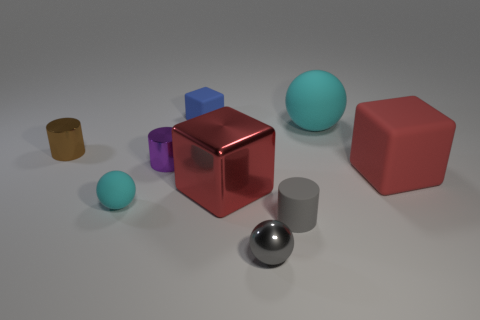How many cyan spheres must be subtracted to get 1 cyan spheres? 1 Subtract all cyan balls. How many balls are left? 1 Subtract 0 gray cubes. How many objects are left? 9 Subtract all balls. How many objects are left? 6 Subtract 1 cubes. How many cubes are left? 2 Subtract all green cylinders. Subtract all red blocks. How many cylinders are left? 3 Subtract all green balls. How many cyan cylinders are left? 0 Subtract all big yellow spheres. Subtract all metallic cylinders. How many objects are left? 7 Add 2 gray rubber cylinders. How many gray rubber cylinders are left? 3 Add 7 blue rubber things. How many blue rubber things exist? 8 